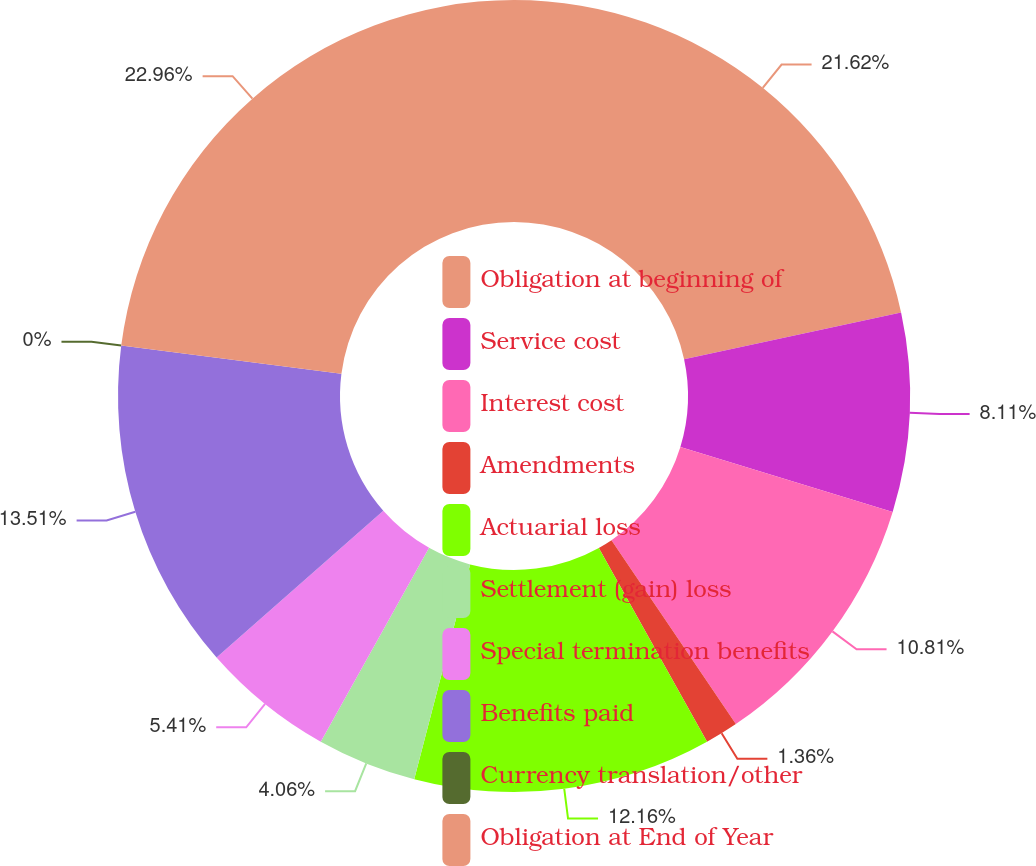Convert chart to OTSL. <chart><loc_0><loc_0><loc_500><loc_500><pie_chart><fcel>Obligation at beginning of<fcel>Service cost<fcel>Interest cost<fcel>Amendments<fcel>Actuarial loss<fcel>Settlement (gain) loss<fcel>Special termination benefits<fcel>Benefits paid<fcel>Currency translation/other<fcel>Obligation at End of Year<nl><fcel>21.62%<fcel>8.11%<fcel>10.81%<fcel>1.36%<fcel>12.16%<fcel>4.06%<fcel>5.41%<fcel>13.51%<fcel>0.0%<fcel>22.97%<nl></chart> 